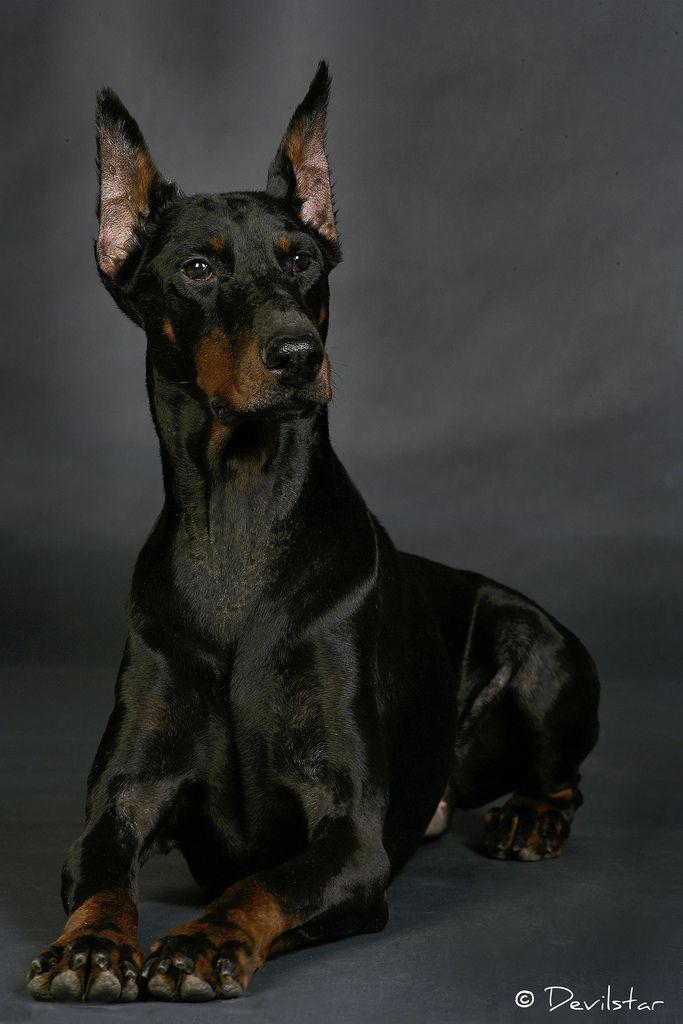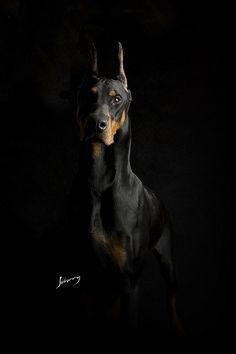The first image is the image on the left, the second image is the image on the right. Given the left and right images, does the statement "Each image contains the same number of dogs, at least one of the dogs depicted gazes straight forward, and all dogs are erect-eared doberman." hold true? Answer yes or no. Yes. The first image is the image on the left, the second image is the image on the right. For the images displayed, is the sentence "The left image contains at least two dogs." factually correct? Answer yes or no. No. 